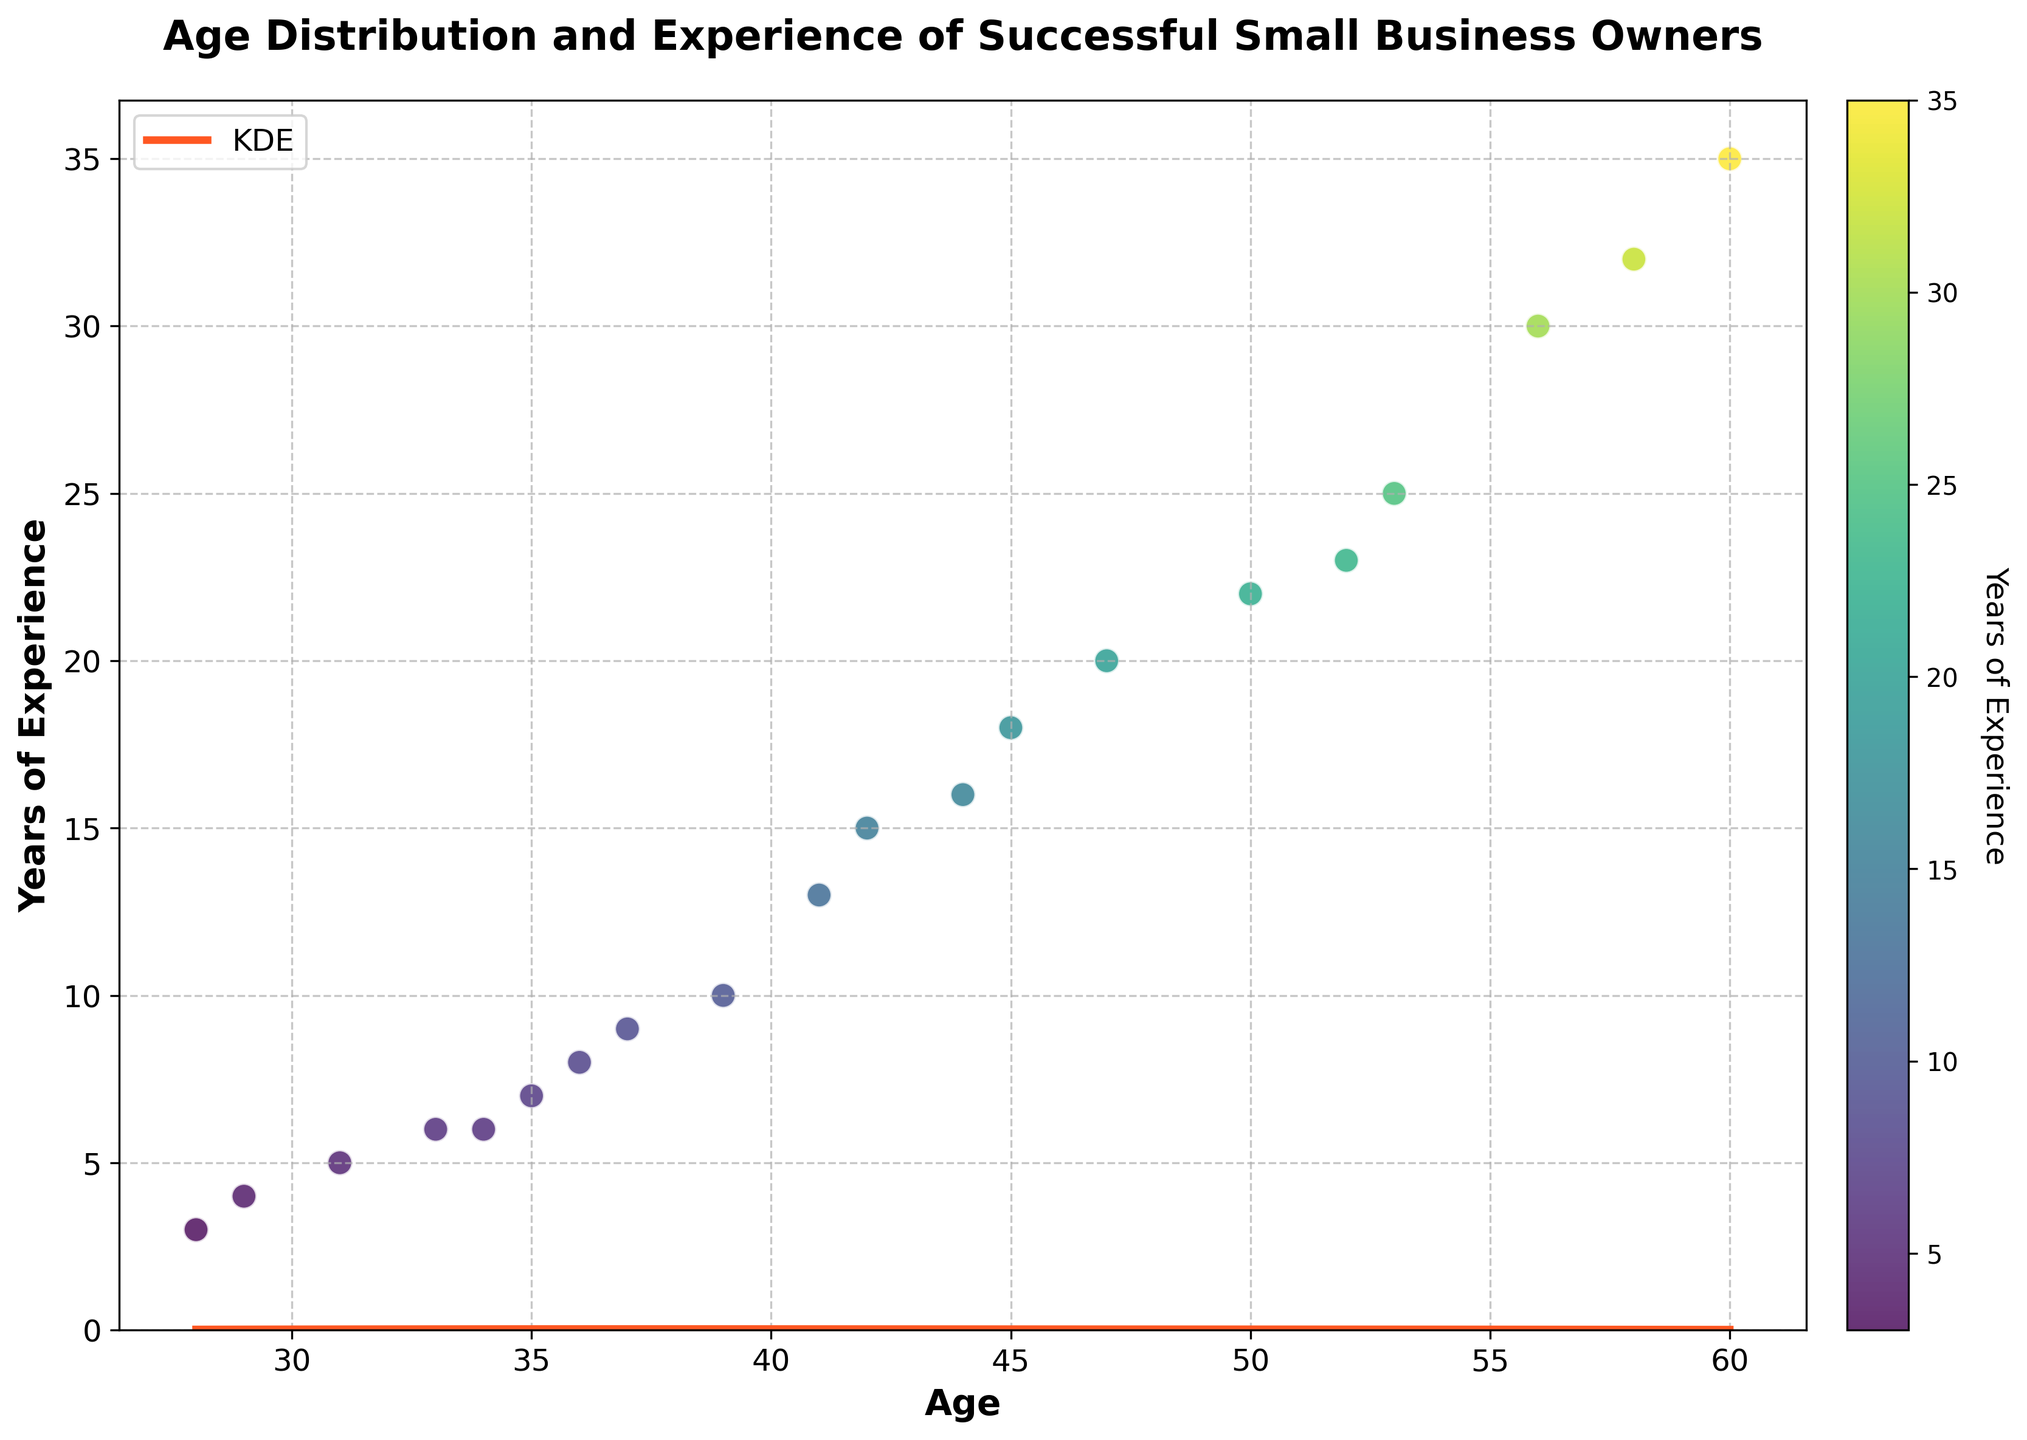What's the title of the figure? The title of the figure is located at the top and ready to glean the main subject of the plot.
Answer: Age Distribution and Experience of Successful Small Business Owners What do the x-axis and y-axis represent? The x-axis represents age, as indicated by the label 'Age.' The y-axis represents years of experience, as indicated by the label 'Years of Experience.'
Answer: Age and Years of Experience Which color represents the KDE curve on the plot? The KDE curve is represented by the color orange, as shown by the plotted line on the graph.
Answer: Orange How many age bins are used in the histogram? By counting the distinct bars, you can see that there are 15 bins in the histogram.
Answer: 15 What is the relationship between age and years of experience visible in the scatter plot? The scatter plot shows a positive correlation, meaning that as age increases, years of experience also tend to increase.
Answer: Positive correlation Which age group has the highest density according to the KDE curve? The highest point of the KDE curve indicates the age group with the highest density. This peak appears around the age of 45 to 50.
Answer: 45-50 years old Are there more small business owners under 40 or over 50? By examining the histogram, we see that the bars are more numerous and taller under the age of 40 compared to those over 50. This suggests that there are more small business owners under 40.
Answer: Under 40 Compare the density of small business owners aged 30-35 to those aged 55-60. Which group is larger? The height of the histogram bars for ages 30-35 is taller than those for 55-60. Thus, the density of small business owners aged 30-35 is larger.
Answer: 30-35 years old What can you infer about small business owners with more than 30 years of experience based on the scatter plot? These business owners are generally older than 55, as indicated by the scattered points with high experience levels appearing in this age range.
Answer: Older than 55 What is the approximate peak density value on the KDE curve? The peak density value on the KDE curve is determined by looking at the highest point of the curve, which appears to be around 0.05.
Answer: ~0.05 